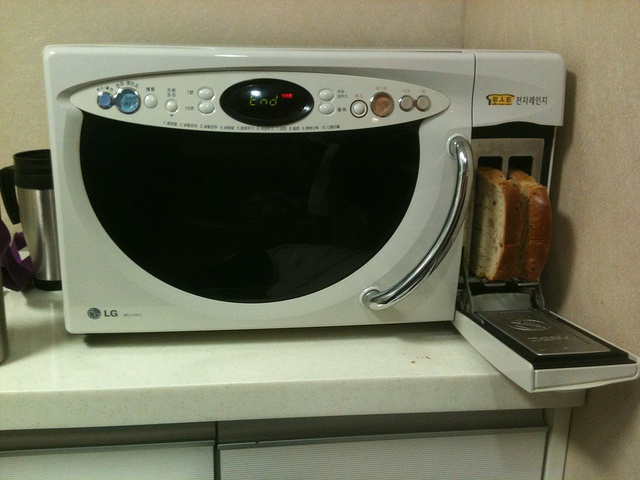Describe the objects in this image and their specific colors. I can see microwave in darkgray, black, and gray tones, toaster in darkgray, black, darkgreen, and maroon tones, and cup in darkgray, black, darkgreen, gray, and tan tones in this image. 